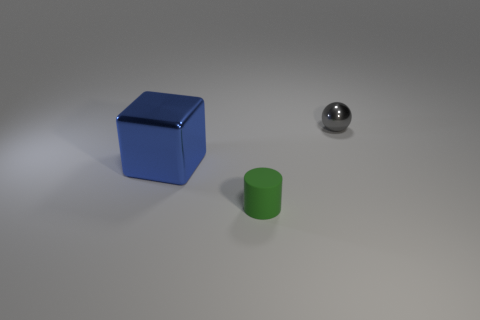Subtract 1 blocks. How many blocks are left? 0 Add 3 shiny objects. How many objects exist? 6 Subtract all gray spheres. How many red cubes are left? 0 Subtract all big gray balls. Subtract all large shiny objects. How many objects are left? 2 Add 1 big blue shiny cubes. How many big blue shiny cubes are left? 2 Add 2 large metallic cubes. How many large metallic cubes exist? 3 Subtract 0 cyan blocks. How many objects are left? 3 Subtract all spheres. How many objects are left? 2 